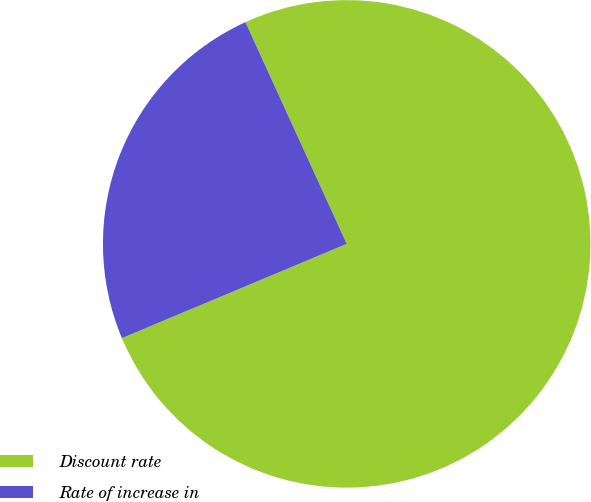Convert chart. <chart><loc_0><loc_0><loc_500><loc_500><pie_chart><fcel>Discount rate<fcel>Rate of increase in<nl><fcel>75.5%<fcel>24.5%<nl></chart> 